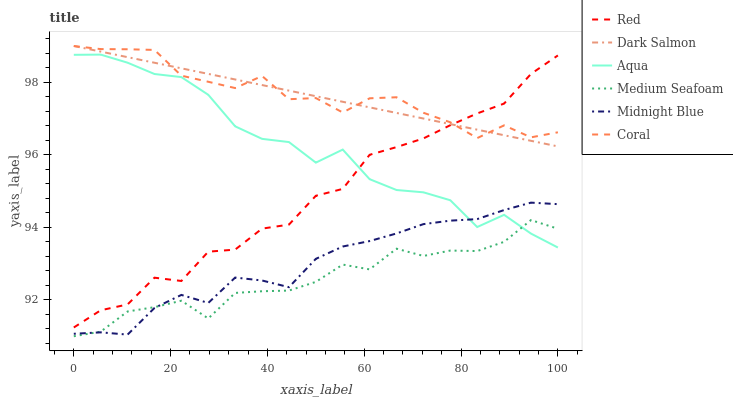Does Medium Seafoam have the minimum area under the curve?
Answer yes or no. Yes. Does Coral have the maximum area under the curve?
Answer yes or no. Yes. Does Aqua have the minimum area under the curve?
Answer yes or no. No. Does Aqua have the maximum area under the curve?
Answer yes or no. No. Is Dark Salmon the smoothest?
Answer yes or no. Yes. Is Red the roughest?
Answer yes or no. Yes. Is Coral the smoothest?
Answer yes or no. No. Is Coral the roughest?
Answer yes or no. No. Does Medium Seafoam have the lowest value?
Answer yes or no. Yes. Does Aqua have the lowest value?
Answer yes or no. No. Does Dark Salmon have the highest value?
Answer yes or no. Yes. Does Aqua have the highest value?
Answer yes or no. No. Is Midnight Blue less than Dark Salmon?
Answer yes or no. Yes. Is Red greater than Medium Seafoam?
Answer yes or no. Yes. Does Dark Salmon intersect Red?
Answer yes or no. Yes. Is Dark Salmon less than Red?
Answer yes or no. No. Is Dark Salmon greater than Red?
Answer yes or no. No. Does Midnight Blue intersect Dark Salmon?
Answer yes or no. No. 